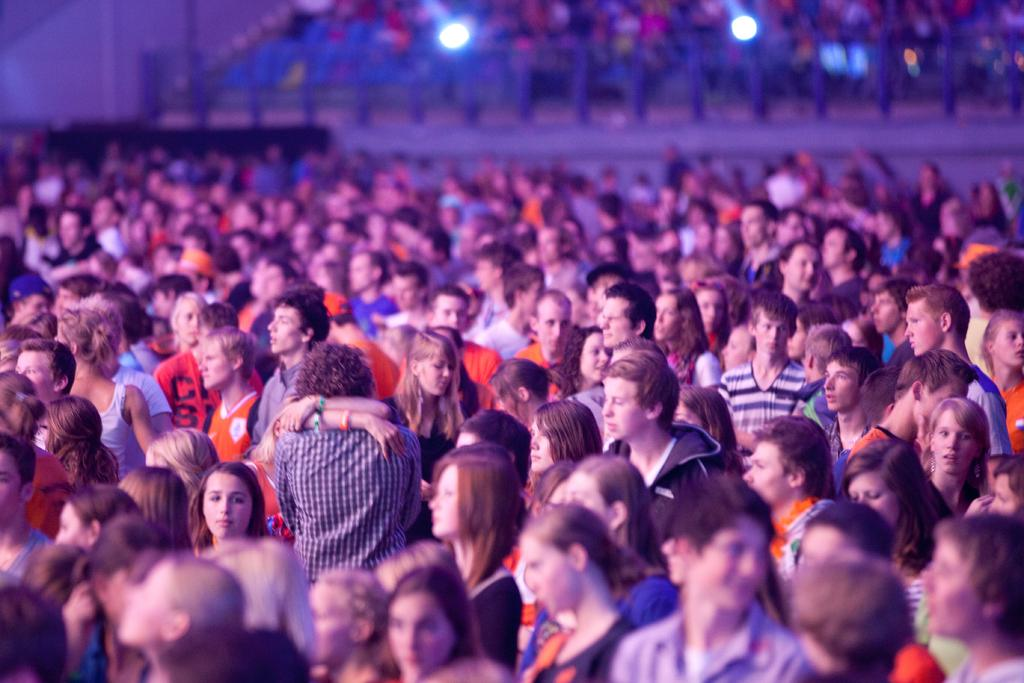How many people can be seen in the image? There are many persons standing on the ground in the image. What can be seen in the background of the image? There is fencing and lights visible in the background of the image. Are there any other people visible in the background? Yes, there are additional persons visible in the background of the image. Is there an island in the image where the people can relax? There is no island present in the image; it features a group of people standing on the ground with fencing and lights in the background. 